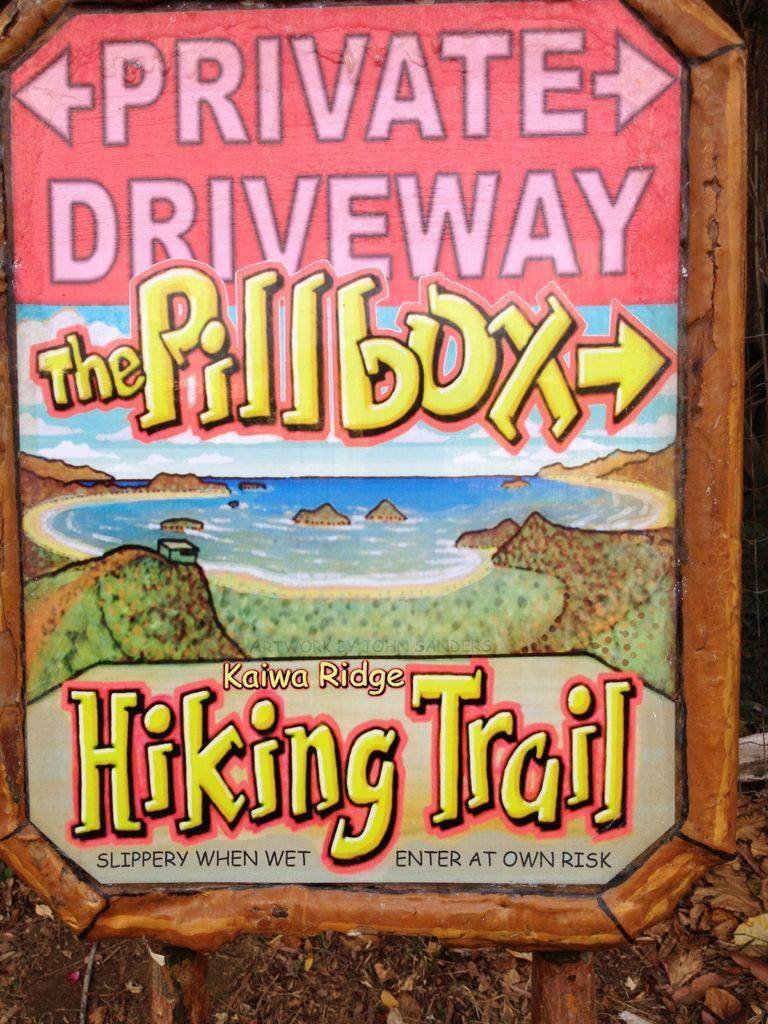<image>
Describe the image concisely. colorful sign for the kaiwa ridge hiking trail that features picture of hills, rocks, and a beach 